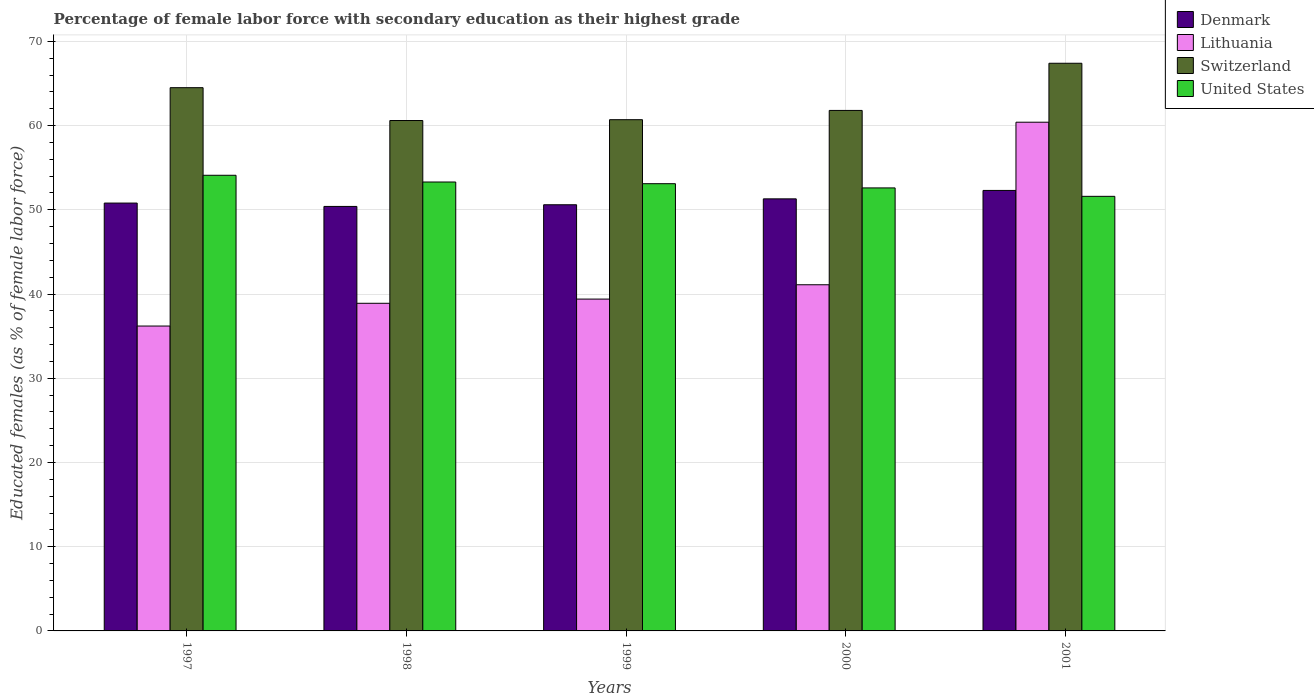Are the number of bars per tick equal to the number of legend labels?
Your answer should be very brief. Yes. In how many cases, is the number of bars for a given year not equal to the number of legend labels?
Offer a terse response. 0. What is the percentage of female labor force with secondary education in United States in 1997?
Your response must be concise. 54.1. Across all years, what is the maximum percentage of female labor force with secondary education in United States?
Your answer should be compact. 54.1. Across all years, what is the minimum percentage of female labor force with secondary education in Denmark?
Your answer should be very brief. 50.4. In which year was the percentage of female labor force with secondary education in Denmark maximum?
Give a very brief answer. 2001. In which year was the percentage of female labor force with secondary education in Switzerland minimum?
Your response must be concise. 1998. What is the total percentage of female labor force with secondary education in United States in the graph?
Provide a succinct answer. 264.7. What is the difference between the percentage of female labor force with secondary education in Denmark in 1997 and that in 2001?
Offer a very short reply. -1.5. What is the difference between the percentage of female labor force with secondary education in United States in 2000 and the percentage of female labor force with secondary education in Denmark in 2001?
Your answer should be very brief. 0.3. What is the average percentage of female labor force with secondary education in Lithuania per year?
Ensure brevity in your answer.  43.2. In the year 2000, what is the difference between the percentage of female labor force with secondary education in United States and percentage of female labor force with secondary education in Lithuania?
Keep it short and to the point. 11.5. What is the ratio of the percentage of female labor force with secondary education in Denmark in 1997 to that in 1999?
Offer a very short reply. 1. What is the difference between the highest and the second highest percentage of female labor force with secondary education in United States?
Provide a succinct answer. 0.8. What is the difference between the highest and the lowest percentage of female labor force with secondary education in Denmark?
Ensure brevity in your answer.  1.9. In how many years, is the percentage of female labor force with secondary education in Switzerland greater than the average percentage of female labor force with secondary education in Switzerland taken over all years?
Your response must be concise. 2. Is it the case that in every year, the sum of the percentage of female labor force with secondary education in Switzerland and percentage of female labor force with secondary education in Lithuania is greater than the sum of percentage of female labor force with secondary education in Denmark and percentage of female labor force with secondary education in United States?
Keep it short and to the point. Yes. What does the 4th bar from the left in 1999 represents?
Make the answer very short. United States. Are all the bars in the graph horizontal?
Offer a very short reply. No. How many years are there in the graph?
Give a very brief answer. 5. What is the difference between two consecutive major ticks on the Y-axis?
Make the answer very short. 10. Does the graph contain grids?
Offer a very short reply. Yes. How many legend labels are there?
Keep it short and to the point. 4. How are the legend labels stacked?
Provide a short and direct response. Vertical. What is the title of the graph?
Ensure brevity in your answer.  Percentage of female labor force with secondary education as their highest grade. What is the label or title of the X-axis?
Ensure brevity in your answer.  Years. What is the label or title of the Y-axis?
Provide a short and direct response. Educated females (as % of female labor force). What is the Educated females (as % of female labor force) of Denmark in 1997?
Provide a short and direct response. 50.8. What is the Educated females (as % of female labor force) of Lithuania in 1997?
Provide a succinct answer. 36.2. What is the Educated females (as % of female labor force) of Switzerland in 1997?
Provide a succinct answer. 64.5. What is the Educated females (as % of female labor force) in United States in 1997?
Your answer should be compact. 54.1. What is the Educated females (as % of female labor force) of Denmark in 1998?
Give a very brief answer. 50.4. What is the Educated females (as % of female labor force) in Lithuania in 1998?
Give a very brief answer. 38.9. What is the Educated females (as % of female labor force) in Switzerland in 1998?
Your answer should be very brief. 60.6. What is the Educated females (as % of female labor force) of United States in 1998?
Make the answer very short. 53.3. What is the Educated females (as % of female labor force) in Denmark in 1999?
Offer a terse response. 50.6. What is the Educated females (as % of female labor force) of Lithuania in 1999?
Your response must be concise. 39.4. What is the Educated females (as % of female labor force) in Switzerland in 1999?
Ensure brevity in your answer.  60.7. What is the Educated females (as % of female labor force) of United States in 1999?
Make the answer very short. 53.1. What is the Educated females (as % of female labor force) in Denmark in 2000?
Your answer should be very brief. 51.3. What is the Educated females (as % of female labor force) of Lithuania in 2000?
Keep it short and to the point. 41.1. What is the Educated females (as % of female labor force) in Switzerland in 2000?
Provide a short and direct response. 61.8. What is the Educated females (as % of female labor force) of United States in 2000?
Keep it short and to the point. 52.6. What is the Educated females (as % of female labor force) of Denmark in 2001?
Provide a short and direct response. 52.3. What is the Educated females (as % of female labor force) in Lithuania in 2001?
Make the answer very short. 60.4. What is the Educated females (as % of female labor force) in Switzerland in 2001?
Provide a succinct answer. 67.4. What is the Educated females (as % of female labor force) of United States in 2001?
Give a very brief answer. 51.6. Across all years, what is the maximum Educated females (as % of female labor force) of Denmark?
Offer a terse response. 52.3. Across all years, what is the maximum Educated females (as % of female labor force) of Lithuania?
Make the answer very short. 60.4. Across all years, what is the maximum Educated females (as % of female labor force) of Switzerland?
Give a very brief answer. 67.4. Across all years, what is the maximum Educated females (as % of female labor force) of United States?
Provide a succinct answer. 54.1. Across all years, what is the minimum Educated females (as % of female labor force) in Denmark?
Your answer should be compact. 50.4. Across all years, what is the minimum Educated females (as % of female labor force) in Lithuania?
Offer a very short reply. 36.2. Across all years, what is the minimum Educated females (as % of female labor force) of Switzerland?
Offer a very short reply. 60.6. Across all years, what is the minimum Educated females (as % of female labor force) in United States?
Ensure brevity in your answer.  51.6. What is the total Educated females (as % of female labor force) of Denmark in the graph?
Make the answer very short. 255.4. What is the total Educated females (as % of female labor force) of Lithuania in the graph?
Your answer should be compact. 216. What is the total Educated females (as % of female labor force) in Switzerland in the graph?
Offer a terse response. 315. What is the total Educated females (as % of female labor force) in United States in the graph?
Offer a terse response. 264.7. What is the difference between the Educated females (as % of female labor force) of Denmark in 1997 and that in 1998?
Provide a short and direct response. 0.4. What is the difference between the Educated females (as % of female labor force) of Lithuania in 1997 and that in 1998?
Your answer should be very brief. -2.7. What is the difference between the Educated females (as % of female labor force) of Switzerland in 1997 and that in 1998?
Give a very brief answer. 3.9. What is the difference between the Educated females (as % of female labor force) in Switzerland in 1997 and that in 1999?
Provide a short and direct response. 3.8. What is the difference between the Educated females (as % of female labor force) of Lithuania in 1997 and that in 2000?
Provide a succinct answer. -4.9. What is the difference between the Educated females (as % of female labor force) of United States in 1997 and that in 2000?
Give a very brief answer. 1.5. What is the difference between the Educated females (as % of female labor force) of Lithuania in 1997 and that in 2001?
Give a very brief answer. -24.2. What is the difference between the Educated females (as % of female labor force) in Switzerland in 1997 and that in 2001?
Ensure brevity in your answer.  -2.9. What is the difference between the Educated females (as % of female labor force) in United States in 1998 and that in 1999?
Ensure brevity in your answer.  0.2. What is the difference between the Educated females (as % of female labor force) in Denmark in 1998 and that in 2000?
Give a very brief answer. -0.9. What is the difference between the Educated females (as % of female labor force) in Lithuania in 1998 and that in 2000?
Offer a terse response. -2.2. What is the difference between the Educated females (as % of female labor force) in United States in 1998 and that in 2000?
Offer a terse response. 0.7. What is the difference between the Educated females (as % of female labor force) of Lithuania in 1998 and that in 2001?
Offer a terse response. -21.5. What is the difference between the Educated females (as % of female labor force) in Switzerland in 1998 and that in 2001?
Your answer should be compact. -6.8. What is the difference between the Educated females (as % of female labor force) in United States in 1998 and that in 2001?
Give a very brief answer. 1.7. What is the difference between the Educated females (as % of female labor force) of Denmark in 1999 and that in 2000?
Ensure brevity in your answer.  -0.7. What is the difference between the Educated females (as % of female labor force) of Lithuania in 1999 and that in 2000?
Your answer should be compact. -1.7. What is the difference between the Educated females (as % of female labor force) of Switzerland in 1999 and that in 2000?
Give a very brief answer. -1.1. What is the difference between the Educated females (as % of female labor force) in Denmark in 1999 and that in 2001?
Make the answer very short. -1.7. What is the difference between the Educated females (as % of female labor force) in Switzerland in 1999 and that in 2001?
Offer a very short reply. -6.7. What is the difference between the Educated females (as % of female labor force) of Lithuania in 2000 and that in 2001?
Your answer should be compact. -19.3. What is the difference between the Educated females (as % of female labor force) of United States in 2000 and that in 2001?
Provide a short and direct response. 1. What is the difference between the Educated females (as % of female labor force) in Denmark in 1997 and the Educated females (as % of female labor force) in Lithuania in 1998?
Your response must be concise. 11.9. What is the difference between the Educated females (as % of female labor force) in Lithuania in 1997 and the Educated females (as % of female labor force) in Switzerland in 1998?
Give a very brief answer. -24.4. What is the difference between the Educated females (as % of female labor force) of Lithuania in 1997 and the Educated females (as % of female labor force) of United States in 1998?
Keep it short and to the point. -17.1. What is the difference between the Educated females (as % of female labor force) in Switzerland in 1997 and the Educated females (as % of female labor force) in United States in 1998?
Give a very brief answer. 11.2. What is the difference between the Educated females (as % of female labor force) of Denmark in 1997 and the Educated females (as % of female labor force) of Lithuania in 1999?
Give a very brief answer. 11.4. What is the difference between the Educated females (as % of female labor force) of Denmark in 1997 and the Educated females (as % of female labor force) of Switzerland in 1999?
Your answer should be very brief. -9.9. What is the difference between the Educated females (as % of female labor force) in Denmark in 1997 and the Educated females (as % of female labor force) in United States in 1999?
Make the answer very short. -2.3. What is the difference between the Educated females (as % of female labor force) in Lithuania in 1997 and the Educated females (as % of female labor force) in Switzerland in 1999?
Offer a very short reply. -24.5. What is the difference between the Educated females (as % of female labor force) in Lithuania in 1997 and the Educated females (as % of female labor force) in United States in 1999?
Offer a terse response. -16.9. What is the difference between the Educated females (as % of female labor force) in Denmark in 1997 and the Educated females (as % of female labor force) in Switzerland in 2000?
Make the answer very short. -11. What is the difference between the Educated females (as % of female labor force) of Denmark in 1997 and the Educated females (as % of female labor force) of United States in 2000?
Offer a terse response. -1.8. What is the difference between the Educated females (as % of female labor force) in Lithuania in 1997 and the Educated females (as % of female labor force) in Switzerland in 2000?
Offer a terse response. -25.6. What is the difference between the Educated females (as % of female labor force) of Lithuania in 1997 and the Educated females (as % of female labor force) of United States in 2000?
Ensure brevity in your answer.  -16.4. What is the difference between the Educated females (as % of female labor force) in Denmark in 1997 and the Educated females (as % of female labor force) in Lithuania in 2001?
Your answer should be compact. -9.6. What is the difference between the Educated females (as % of female labor force) of Denmark in 1997 and the Educated females (as % of female labor force) of Switzerland in 2001?
Your response must be concise. -16.6. What is the difference between the Educated females (as % of female labor force) in Denmark in 1997 and the Educated females (as % of female labor force) in United States in 2001?
Ensure brevity in your answer.  -0.8. What is the difference between the Educated females (as % of female labor force) in Lithuania in 1997 and the Educated females (as % of female labor force) in Switzerland in 2001?
Offer a terse response. -31.2. What is the difference between the Educated females (as % of female labor force) of Lithuania in 1997 and the Educated females (as % of female labor force) of United States in 2001?
Keep it short and to the point. -15.4. What is the difference between the Educated females (as % of female labor force) in Denmark in 1998 and the Educated females (as % of female labor force) in Switzerland in 1999?
Make the answer very short. -10.3. What is the difference between the Educated females (as % of female labor force) in Lithuania in 1998 and the Educated females (as % of female labor force) in Switzerland in 1999?
Ensure brevity in your answer.  -21.8. What is the difference between the Educated females (as % of female labor force) of Lithuania in 1998 and the Educated females (as % of female labor force) of United States in 1999?
Keep it short and to the point. -14.2. What is the difference between the Educated females (as % of female labor force) in Lithuania in 1998 and the Educated females (as % of female labor force) in Switzerland in 2000?
Your response must be concise. -22.9. What is the difference between the Educated females (as % of female labor force) of Lithuania in 1998 and the Educated females (as % of female labor force) of United States in 2000?
Provide a succinct answer. -13.7. What is the difference between the Educated females (as % of female labor force) of Switzerland in 1998 and the Educated females (as % of female labor force) of United States in 2000?
Provide a short and direct response. 8. What is the difference between the Educated females (as % of female labor force) in Denmark in 1998 and the Educated females (as % of female labor force) in Lithuania in 2001?
Ensure brevity in your answer.  -10. What is the difference between the Educated females (as % of female labor force) of Denmark in 1998 and the Educated females (as % of female labor force) of United States in 2001?
Make the answer very short. -1.2. What is the difference between the Educated females (as % of female labor force) in Lithuania in 1998 and the Educated females (as % of female labor force) in Switzerland in 2001?
Your answer should be compact. -28.5. What is the difference between the Educated females (as % of female labor force) in Switzerland in 1998 and the Educated females (as % of female labor force) in United States in 2001?
Your answer should be very brief. 9. What is the difference between the Educated females (as % of female labor force) of Denmark in 1999 and the Educated females (as % of female labor force) of United States in 2000?
Offer a terse response. -2. What is the difference between the Educated females (as % of female labor force) in Lithuania in 1999 and the Educated females (as % of female labor force) in Switzerland in 2000?
Give a very brief answer. -22.4. What is the difference between the Educated females (as % of female labor force) in Lithuania in 1999 and the Educated females (as % of female labor force) in United States in 2000?
Keep it short and to the point. -13.2. What is the difference between the Educated females (as % of female labor force) of Denmark in 1999 and the Educated females (as % of female labor force) of Switzerland in 2001?
Ensure brevity in your answer.  -16.8. What is the difference between the Educated females (as % of female labor force) of Lithuania in 1999 and the Educated females (as % of female labor force) of United States in 2001?
Provide a succinct answer. -12.2. What is the difference between the Educated females (as % of female labor force) in Denmark in 2000 and the Educated females (as % of female labor force) in Switzerland in 2001?
Your answer should be very brief. -16.1. What is the difference between the Educated females (as % of female labor force) of Denmark in 2000 and the Educated females (as % of female labor force) of United States in 2001?
Give a very brief answer. -0.3. What is the difference between the Educated females (as % of female labor force) of Lithuania in 2000 and the Educated females (as % of female labor force) of Switzerland in 2001?
Provide a succinct answer. -26.3. What is the difference between the Educated females (as % of female labor force) of Lithuania in 2000 and the Educated females (as % of female labor force) of United States in 2001?
Ensure brevity in your answer.  -10.5. What is the difference between the Educated females (as % of female labor force) in Switzerland in 2000 and the Educated females (as % of female labor force) in United States in 2001?
Your response must be concise. 10.2. What is the average Educated females (as % of female labor force) of Denmark per year?
Offer a very short reply. 51.08. What is the average Educated females (as % of female labor force) of Lithuania per year?
Your answer should be very brief. 43.2. What is the average Educated females (as % of female labor force) of United States per year?
Keep it short and to the point. 52.94. In the year 1997, what is the difference between the Educated females (as % of female labor force) of Denmark and Educated females (as % of female labor force) of Lithuania?
Make the answer very short. 14.6. In the year 1997, what is the difference between the Educated females (as % of female labor force) of Denmark and Educated females (as % of female labor force) of Switzerland?
Keep it short and to the point. -13.7. In the year 1997, what is the difference between the Educated females (as % of female labor force) of Denmark and Educated females (as % of female labor force) of United States?
Make the answer very short. -3.3. In the year 1997, what is the difference between the Educated females (as % of female labor force) of Lithuania and Educated females (as % of female labor force) of Switzerland?
Keep it short and to the point. -28.3. In the year 1997, what is the difference between the Educated females (as % of female labor force) in Lithuania and Educated females (as % of female labor force) in United States?
Make the answer very short. -17.9. In the year 1998, what is the difference between the Educated females (as % of female labor force) in Denmark and Educated females (as % of female labor force) in Lithuania?
Provide a short and direct response. 11.5. In the year 1998, what is the difference between the Educated females (as % of female labor force) in Lithuania and Educated females (as % of female labor force) in Switzerland?
Give a very brief answer. -21.7. In the year 1998, what is the difference between the Educated females (as % of female labor force) of Lithuania and Educated females (as % of female labor force) of United States?
Offer a terse response. -14.4. In the year 1998, what is the difference between the Educated females (as % of female labor force) of Switzerland and Educated females (as % of female labor force) of United States?
Offer a terse response. 7.3. In the year 1999, what is the difference between the Educated females (as % of female labor force) in Denmark and Educated females (as % of female labor force) in Switzerland?
Offer a very short reply. -10.1. In the year 1999, what is the difference between the Educated females (as % of female labor force) of Denmark and Educated females (as % of female labor force) of United States?
Offer a terse response. -2.5. In the year 1999, what is the difference between the Educated females (as % of female labor force) of Lithuania and Educated females (as % of female labor force) of Switzerland?
Provide a succinct answer. -21.3. In the year 1999, what is the difference between the Educated females (as % of female labor force) in Lithuania and Educated females (as % of female labor force) in United States?
Your answer should be compact. -13.7. In the year 2000, what is the difference between the Educated females (as % of female labor force) of Denmark and Educated females (as % of female labor force) of Lithuania?
Offer a terse response. 10.2. In the year 2000, what is the difference between the Educated females (as % of female labor force) of Lithuania and Educated females (as % of female labor force) of Switzerland?
Keep it short and to the point. -20.7. In the year 2000, what is the difference between the Educated females (as % of female labor force) in Lithuania and Educated females (as % of female labor force) in United States?
Make the answer very short. -11.5. In the year 2000, what is the difference between the Educated females (as % of female labor force) of Switzerland and Educated females (as % of female labor force) of United States?
Give a very brief answer. 9.2. In the year 2001, what is the difference between the Educated females (as % of female labor force) in Denmark and Educated females (as % of female labor force) in Switzerland?
Keep it short and to the point. -15.1. In the year 2001, what is the difference between the Educated females (as % of female labor force) of Denmark and Educated females (as % of female labor force) of United States?
Your response must be concise. 0.7. In the year 2001, what is the difference between the Educated females (as % of female labor force) of Lithuania and Educated females (as % of female labor force) of Switzerland?
Your response must be concise. -7. In the year 2001, what is the difference between the Educated females (as % of female labor force) of Lithuania and Educated females (as % of female labor force) of United States?
Offer a terse response. 8.8. In the year 2001, what is the difference between the Educated females (as % of female labor force) in Switzerland and Educated females (as % of female labor force) in United States?
Offer a very short reply. 15.8. What is the ratio of the Educated females (as % of female labor force) in Denmark in 1997 to that in 1998?
Your answer should be compact. 1.01. What is the ratio of the Educated females (as % of female labor force) of Lithuania in 1997 to that in 1998?
Give a very brief answer. 0.93. What is the ratio of the Educated females (as % of female labor force) of Switzerland in 1997 to that in 1998?
Provide a succinct answer. 1.06. What is the ratio of the Educated females (as % of female labor force) of Lithuania in 1997 to that in 1999?
Make the answer very short. 0.92. What is the ratio of the Educated females (as % of female labor force) of Switzerland in 1997 to that in 1999?
Offer a terse response. 1.06. What is the ratio of the Educated females (as % of female labor force) of United States in 1997 to that in 1999?
Ensure brevity in your answer.  1.02. What is the ratio of the Educated females (as % of female labor force) in Denmark in 1997 to that in 2000?
Make the answer very short. 0.99. What is the ratio of the Educated females (as % of female labor force) in Lithuania in 1997 to that in 2000?
Keep it short and to the point. 0.88. What is the ratio of the Educated females (as % of female labor force) of Switzerland in 1997 to that in 2000?
Your response must be concise. 1.04. What is the ratio of the Educated females (as % of female labor force) in United States in 1997 to that in 2000?
Provide a succinct answer. 1.03. What is the ratio of the Educated females (as % of female labor force) of Denmark in 1997 to that in 2001?
Make the answer very short. 0.97. What is the ratio of the Educated females (as % of female labor force) in Lithuania in 1997 to that in 2001?
Your answer should be very brief. 0.6. What is the ratio of the Educated females (as % of female labor force) of Switzerland in 1997 to that in 2001?
Provide a succinct answer. 0.96. What is the ratio of the Educated females (as % of female labor force) in United States in 1997 to that in 2001?
Keep it short and to the point. 1.05. What is the ratio of the Educated females (as % of female labor force) of Lithuania in 1998 to that in 1999?
Offer a very short reply. 0.99. What is the ratio of the Educated females (as % of female labor force) of Switzerland in 1998 to that in 1999?
Offer a very short reply. 1. What is the ratio of the Educated females (as % of female labor force) in Denmark in 1998 to that in 2000?
Make the answer very short. 0.98. What is the ratio of the Educated females (as % of female labor force) of Lithuania in 1998 to that in 2000?
Your response must be concise. 0.95. What is the ratio of the Educated females (as % of female labor force) in Switzerland in 1998 to that in 2000?
Offer a terse response. 0.98. What is the ratio of the Educated females (as % of female labor force) of United States in 1998 to that in 2000?
Your answer should be compact. 1.01. What is the ratio of the Educated females (as % of female labor force) in Denmark in 1998 to that in 2001?
Keep it short and to the point. 0.96. What is the ratio of the Educated females (as % of female labor force) in Lithuania in 1998 to that in 2001?
Your answer should be compact. 0.64. What is the ratio of the Educated females (as % of female labor force) in Switzerland in 1998 to that in 2001?
Make the answer very short. 0.9. What is the ratio of the Educated females (as % of female labor force) of United States in 1998 to that in 2001?
Give a very brief answer. 1.03. What is the ratio of the Educated females (as % of female labor force) in Denmark in 1999 to that in 2000?
Provide a succinct answer. 0.99. What is the ratio of the Educated females (as % of female labor force) of Lithuania in 1999 to that in 2000?
Ensure brevity in your answer.  0.96. What is the ratio of the Educated females (as % of female labor force) in Switzerland in 1999 to that in 2000?
Make the answer very short. 0.98. What is the ratio of the Educated females (as % of female labor force) of United States in 1999 to that in 2000?
Provide a succinct answer. 1.01. What is the ratio of the Educated females (as % of female labor force) of Denmark in 1999 to that in 2001?
Ensure brevity in your answer.  0.97. What is the ratio of the Educated females (as % of female labor force) in Lithuania in 1999 to that in 2001?
Keep it short and to the point. 0.65. What is the ratio of the Educated females (as % of female labor force) in Switzerland in 1999 to that in 2001?
Ensure brevity in your answer.  0.9. What is the ratio of the Educated females (as % of female labor force) in United States in 1999 to that in 2001?
Your response must be concise. 1.03. What is the ratio of the Educated females (as % of female labor force) in Denmark in 2000 to that in 2001?
Provide a succinct answer. 0.98. What is the ratio of the Educated females (as % of female labor force) of Lithuania in 2000 to that in 2001?
Provide a succinct answer. 0.68. What is the ratio of the Educated females (as % of female labor force) of Switzerland in 2000 to that in 2001?
Provide a succinct answer. 0.92. What is the ratio of the Educated females (as % of female labor force) in United States in 2000 to that in 2001?
Provide a short and direct response. 1.02. What is the difference between the highest and the second highest Educated females (as % of female labor force) of Denmark?
Provide a short and direct response. 1. What is the difference between the highest and the second highest Educated females (as % of female labor force) in Lithuania?
Give a very brief answer. 19.3. What is the difference between the highest and the second highest Educated females (as % of female labor force) in Switzerland?
Make the answer very short. 2.9. What is the difference between the highest and the lowest Educated females (as % of female labor force) in Lithuania?
Ensure brevity in your answer.  24.2. 